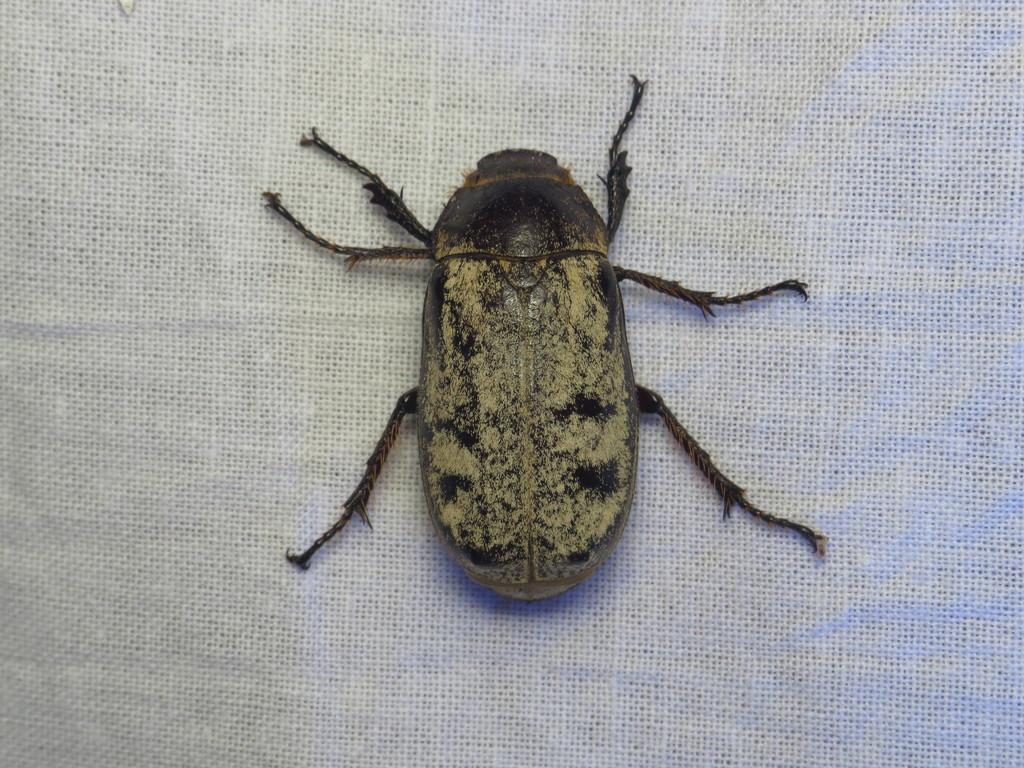What type of creature can be seen in the image? There is an insect in the image. What is the background or surface that the insect is on? The insect is on a white surface. What type of roof can be seen in the image? There is no roof present in the image; it only features an insect on a white surface. Can you tell me how the insect is talking to the other insects in the image? Insects do not have the ability to talk, and there are no other insects visible in the image. 